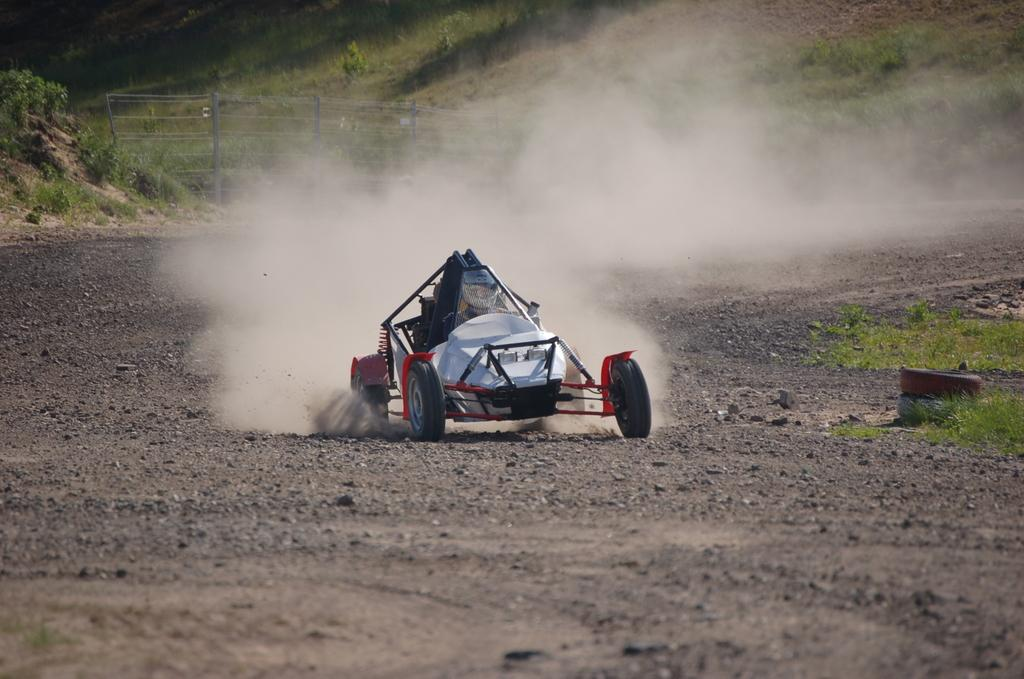What is the main subject in the middle of the image? There is a vehicle on the ground in the middle of the image. What can be seen in the background of the image? There is a fence and grass on the ground in the background of the image. What type of noise can be heard coming from the lead in the image? There is no lead present in the image, and therefore no noise can be heard coming from it. 